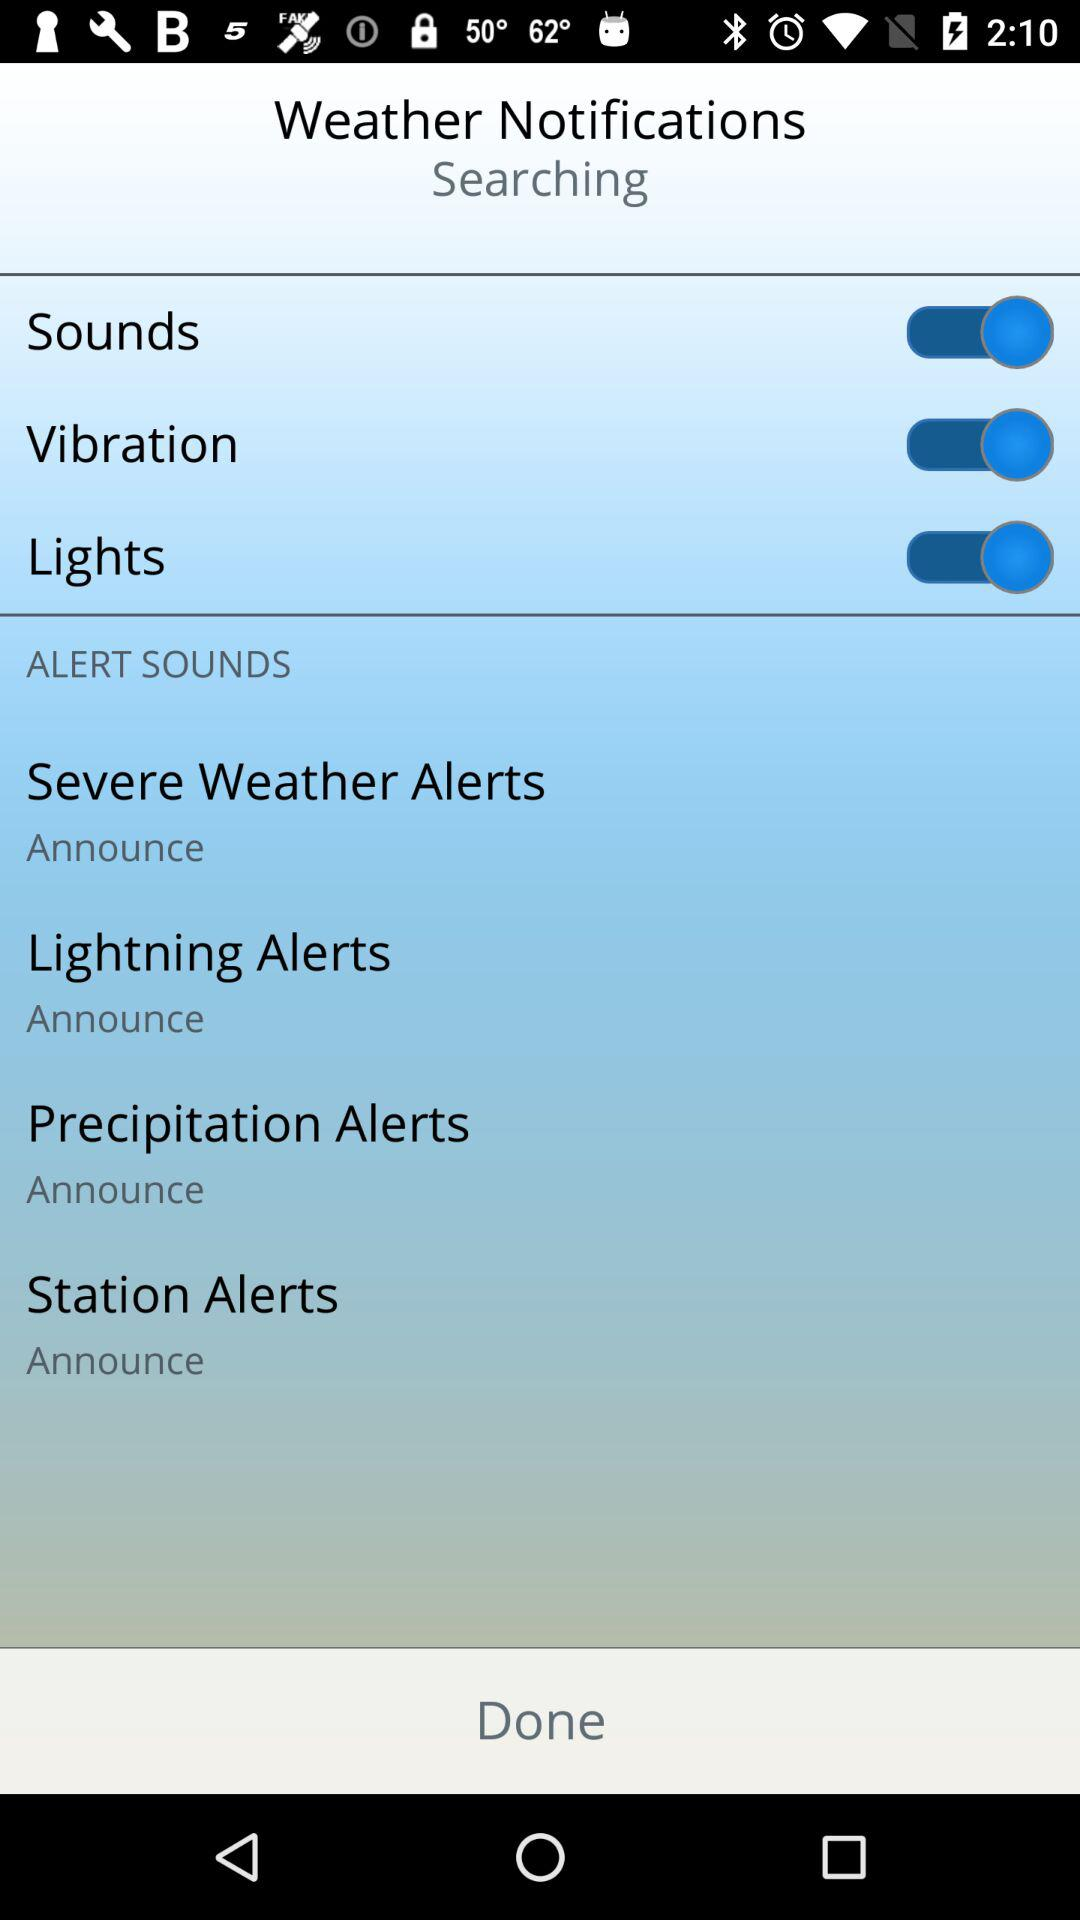What is the current setting for the precipitation alerts? The current setting for the precipitation alerts is "Announce". 